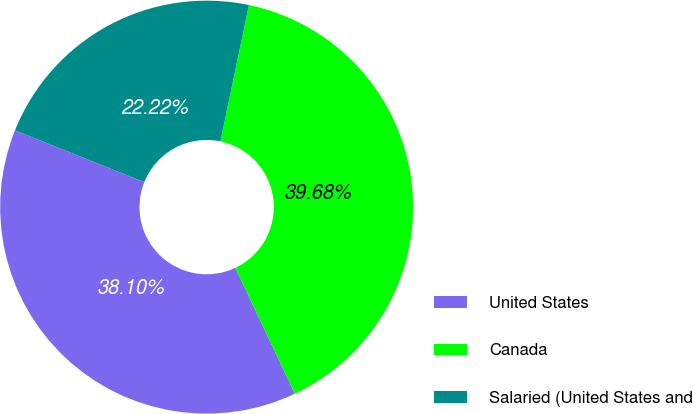<chart> <loc_0><loc_0><loc_500><loc_500><pie_chart><fcel>United States<fcel>Canada<fcel>Salaried (United States and<nl><fcel>38.1%<fcel>39.68%<fcel>22.22%<nl></chart> 